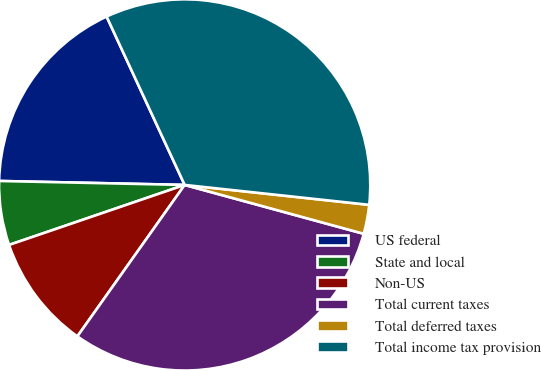<chart> <loc_0><loc_0><loc_500><loc_500><pie_chart><fcel>US federal<fcel>State and local<fcel>Non-US<fcel>Total current taxes<fcel>Total deferred taxes<fcel>Total income tax provision<nl><fcel>17.75%<fcel>5.58%<fcel>9.95%<fcel>30.57%<fcel>2.53%<fcel>33.62%<nl></chart> 